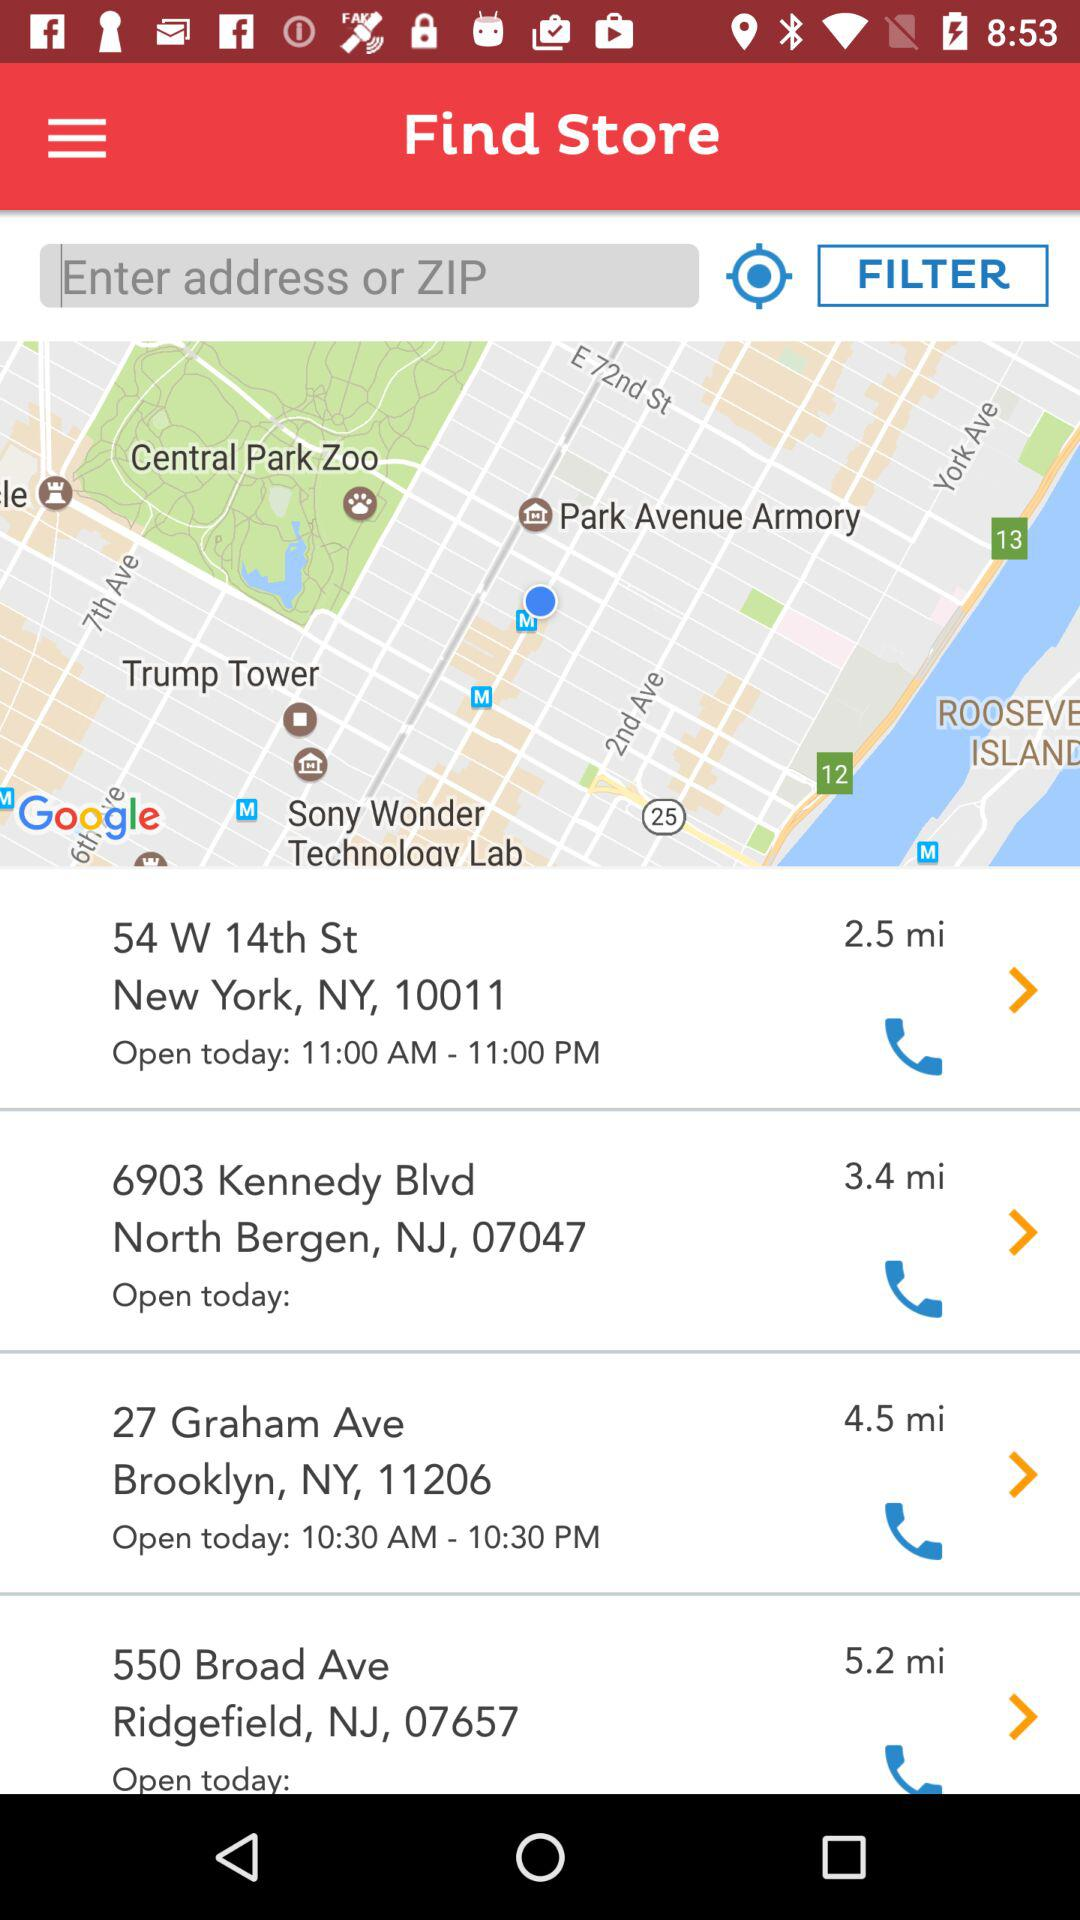How far is the furthest store from the user's location?
Answer the question using a single word or phrase. 5.2 mi 